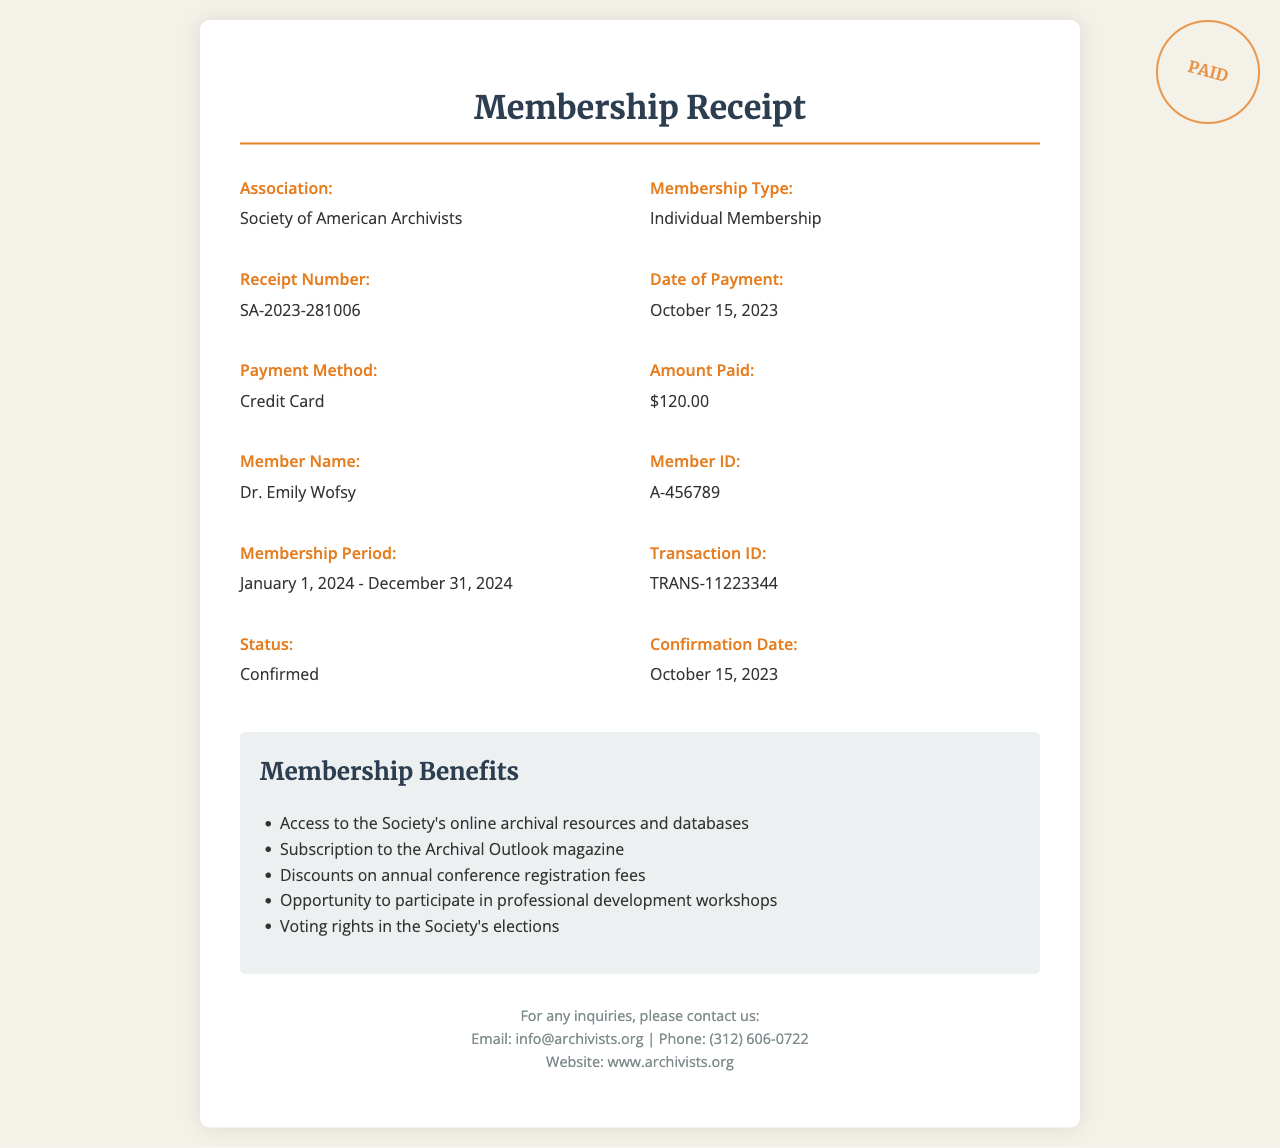What is the name of the association? The document states that the association is the Society of American Archivists.
Answer: Society of American Archivists What is the membership type? According to the document, the membership type is specified as Individual Membership.
Answer: Individual Membership What was the amount paid? The document lists the amount paid as $120.00.
Answer: $120.00 When was the payment made? The document indicates that the payment was made on October 15, 2023.
Answer: October 15, 2023 What is the membership period? The document specifies the membership period as January 1, 2024 - December 31, 2024.
Answer: January 1, 2024 - December 31, 2024 What are the voting rights? The benefits section states that members receive voting rights in the Society's elections.
Answer: Voting rights in the Society's elections What is the member's name? The document lists the member's name as Dr. Emily Wofsy.
Answer: Dr. Emily Wofsy How was the payment made? The document mentions that the payment method used was a credit card.
Answer: Credit Card What is the receipt number? It is specified in the document that the receipt number is SA-2023-281006.
Answer: SA-2023-281006 What is the status of the transaction? The document indicates that the transaction status is confirmed.
Answer: Confirmed 